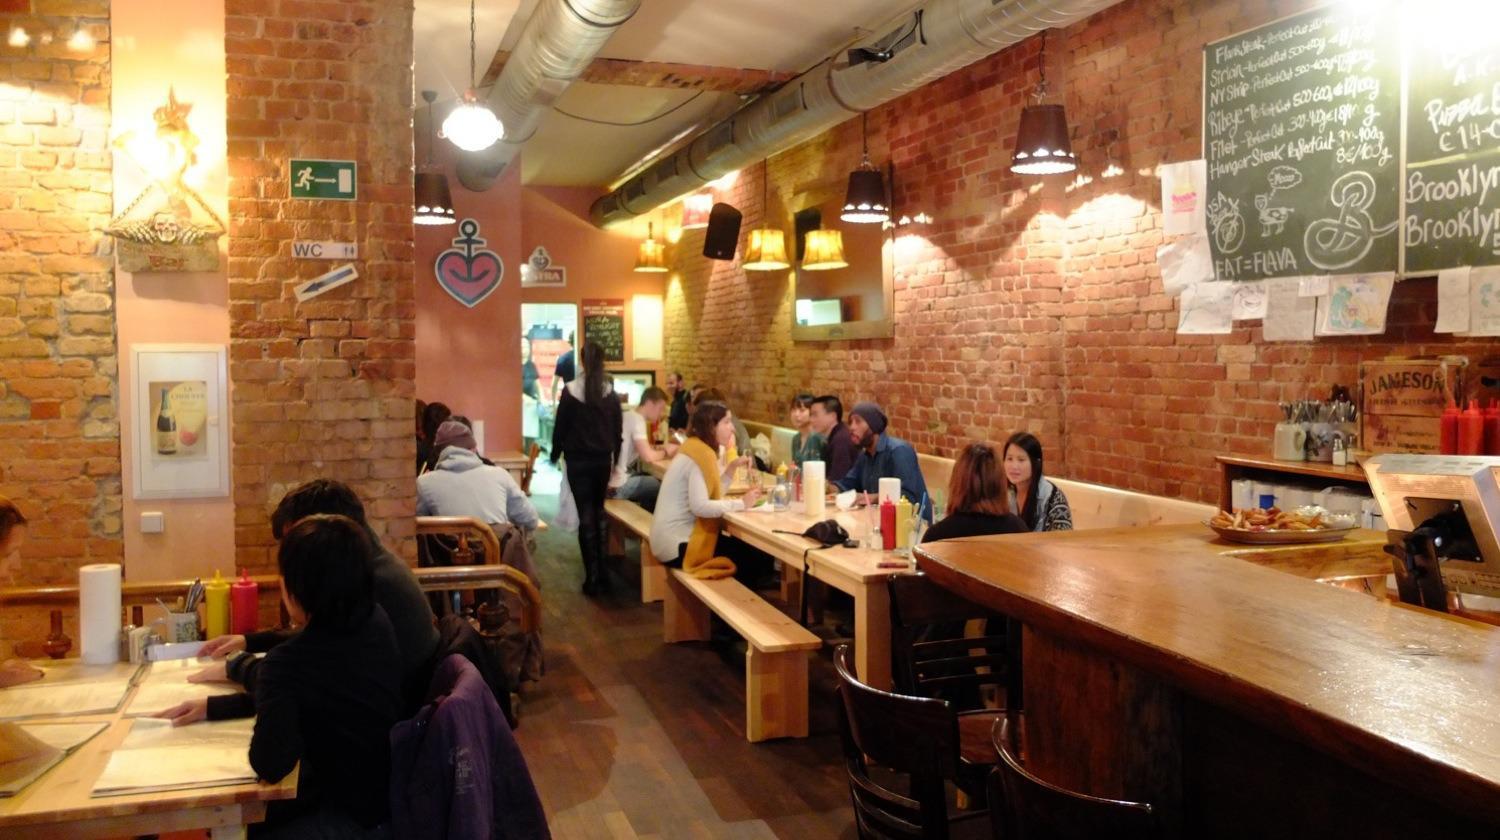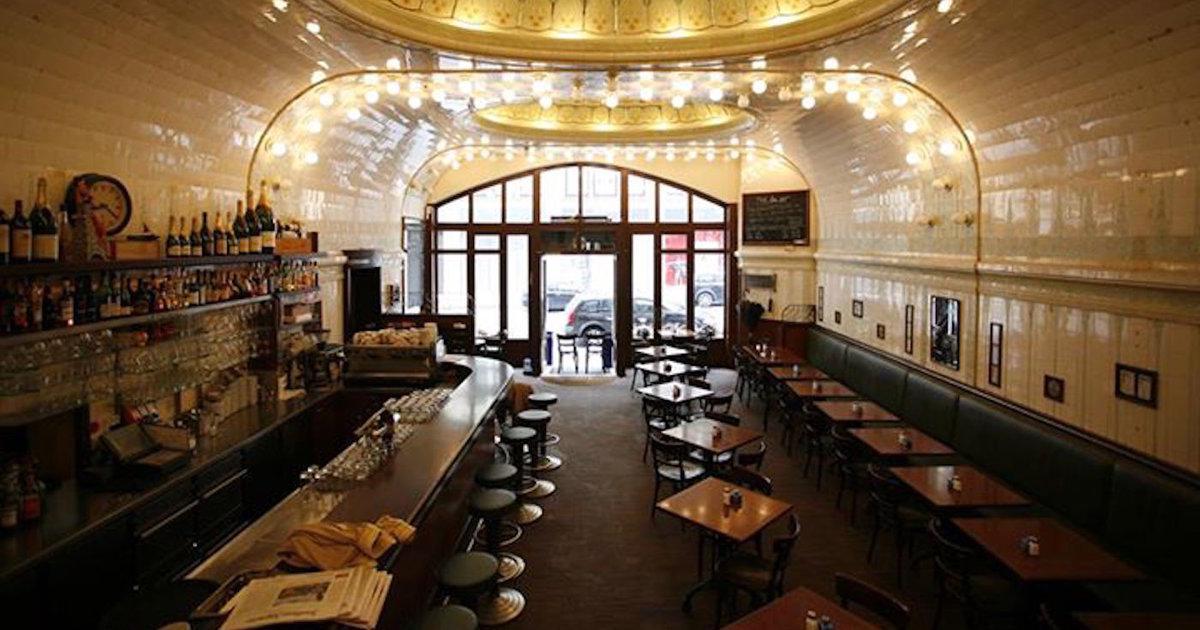The first image is the image on the left, the second image is the image on the right. Analyze the images presented: Is the assertion "One image shows customers in a restaurant and the other shows no customers." valid? Answer yes or no. Yes. The first image is the image on the left, the second image is the image on the right. For the images displayed, is the sentence "In at least one of the images all the chairs are empty." factually correct? Answer yes or no. Yes. 